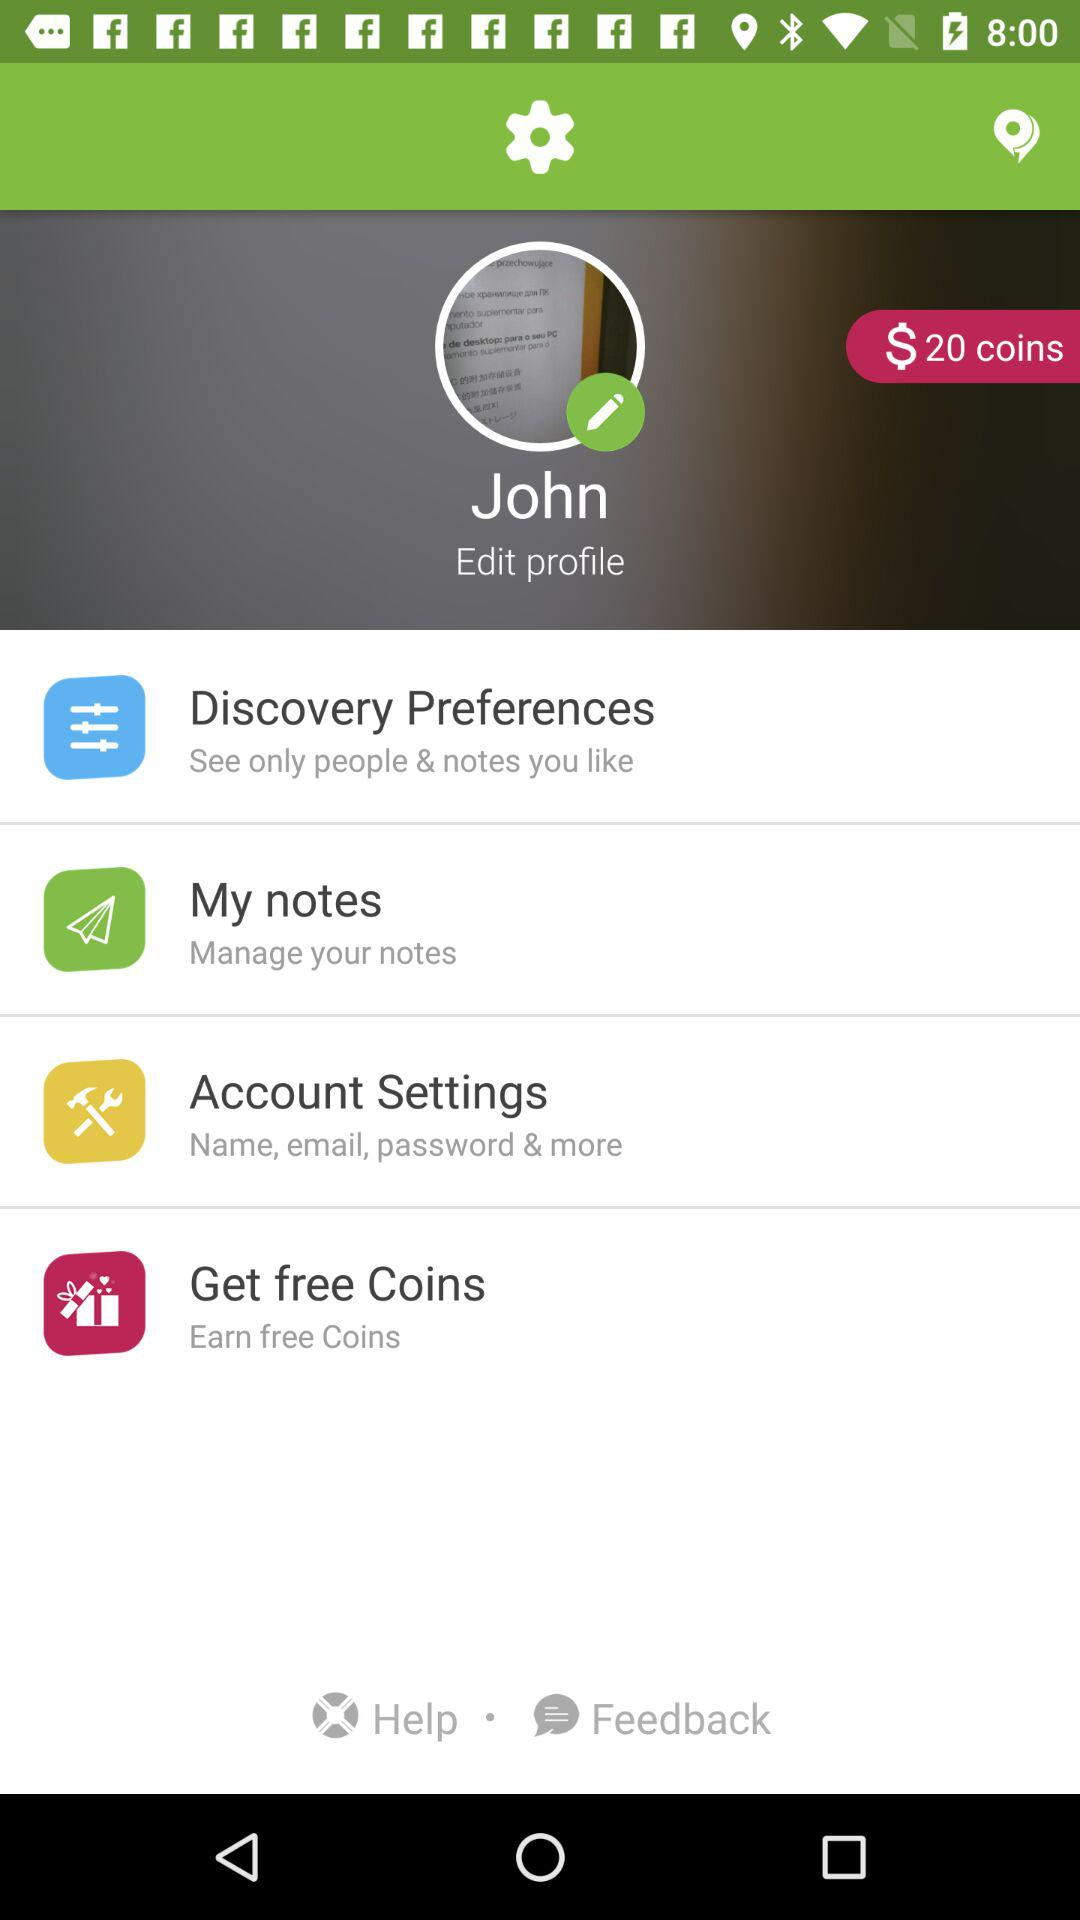What is the user name? The user name is John. 